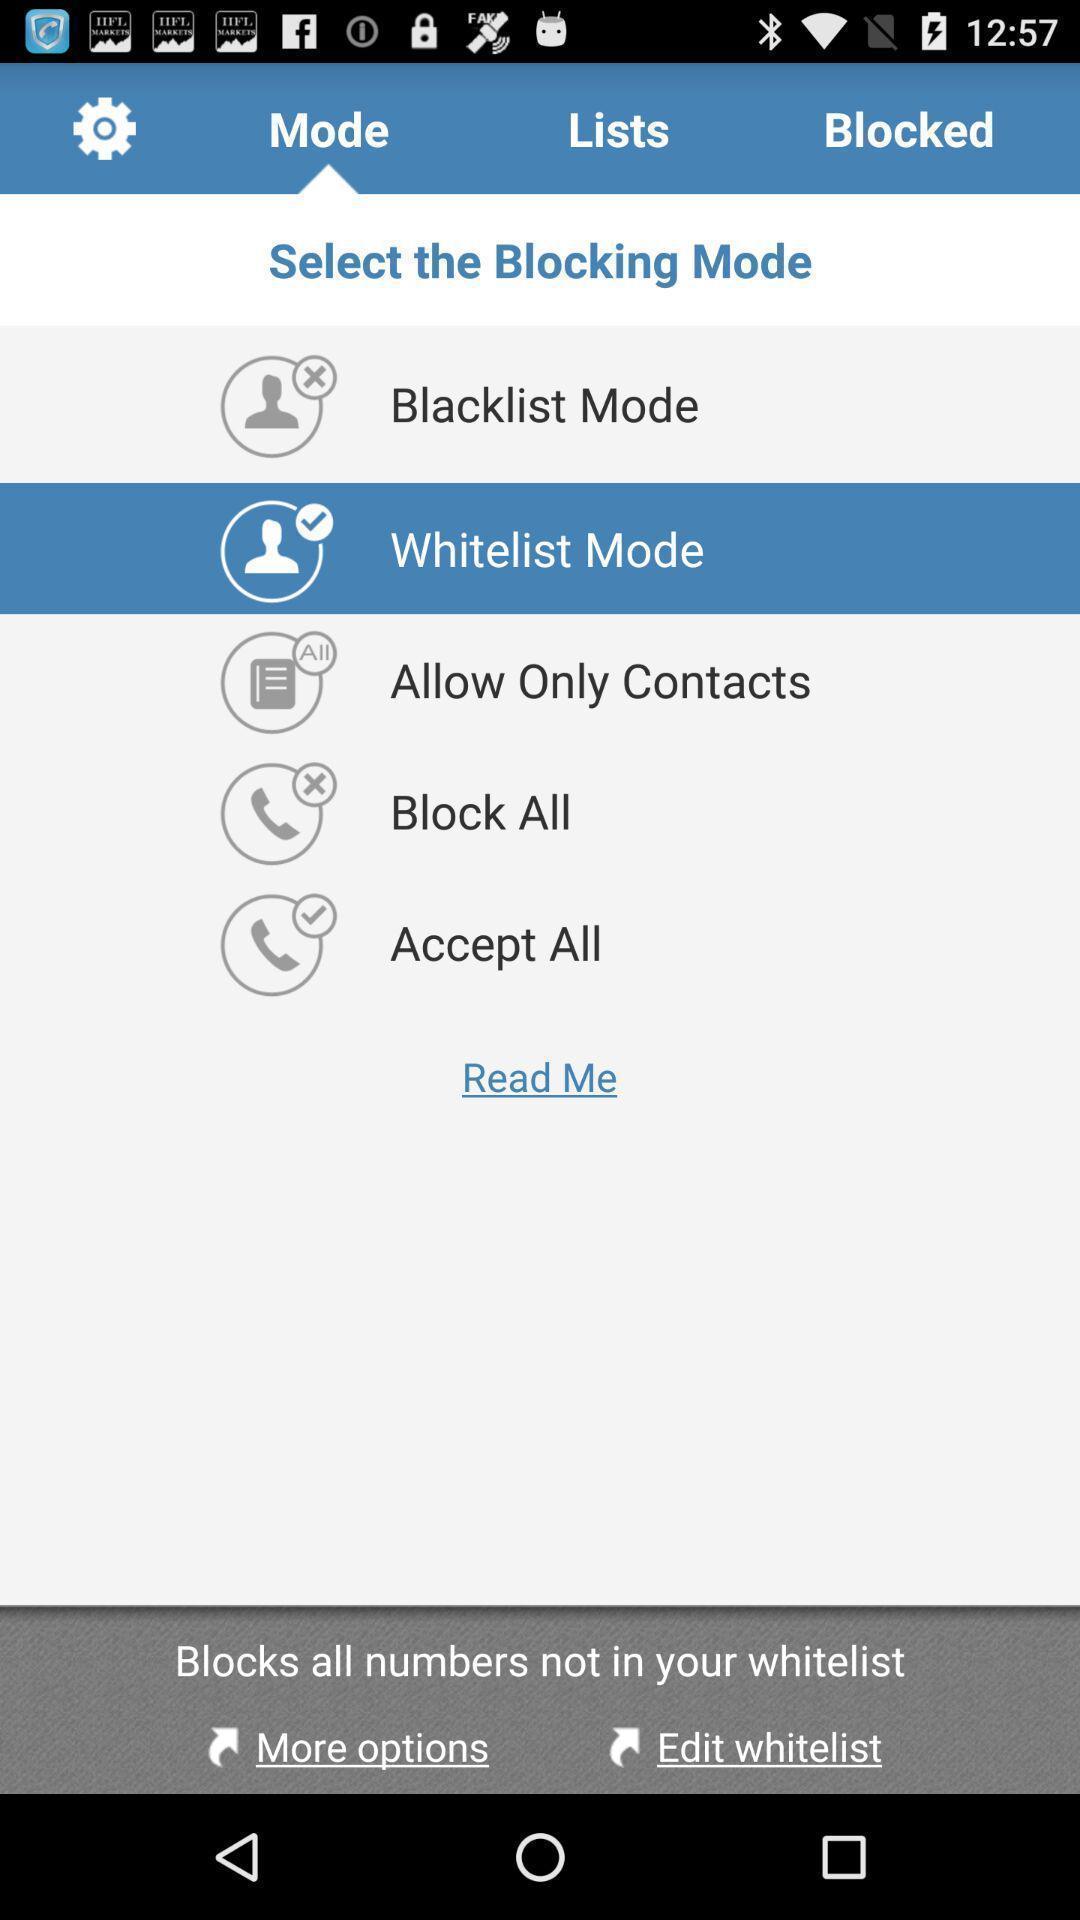What is the overall content of this screenshot? Page for selecting a blocking mode for a call. 